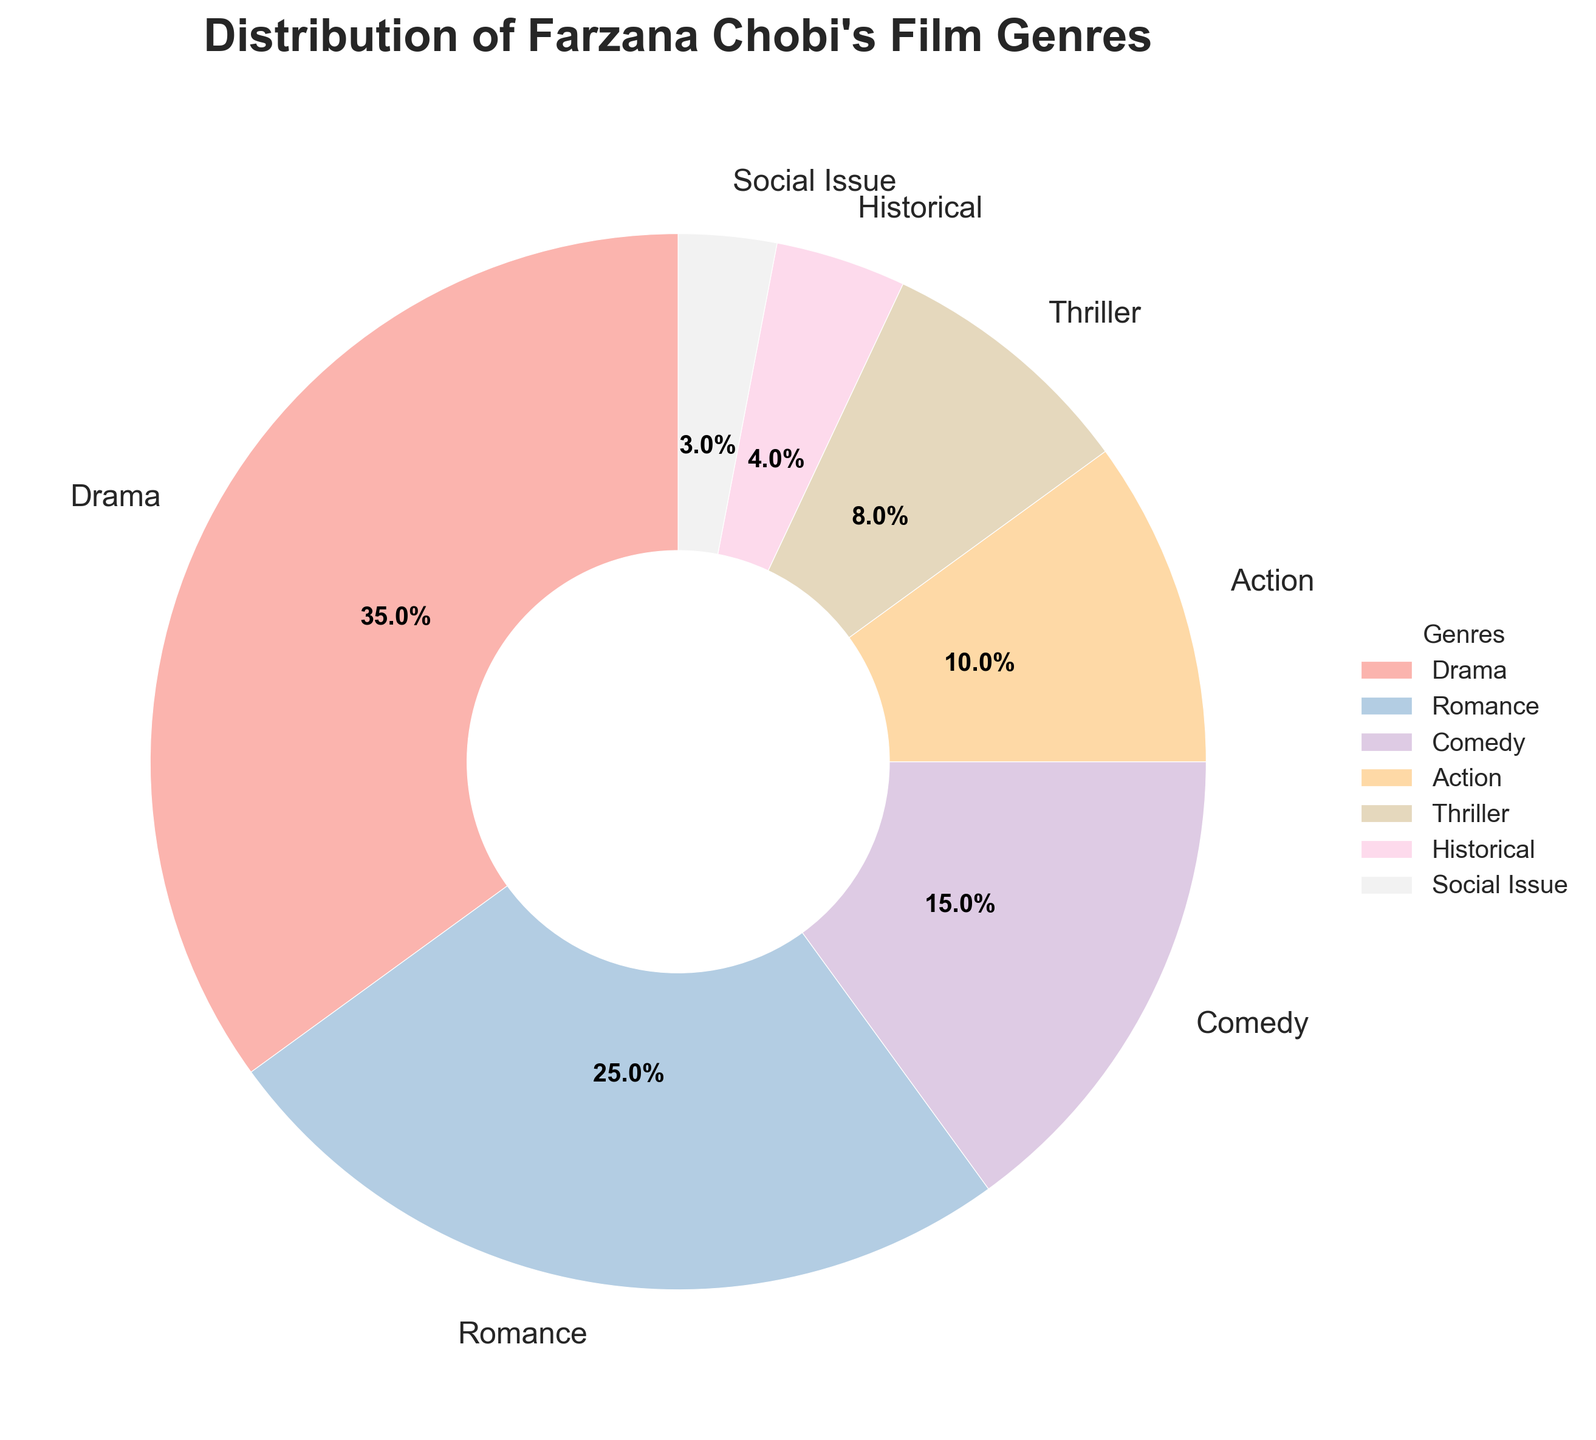What genre constitutes the largest percentage of Farzana Chobi's films? The largest segment on the pie chart is Drama. Hence, Drama constitutes the largest percentage of her films.
Answer: Drama What is the combined percentage of Drama and Romance films? From the chart, Drama is 35% and Romance is 25%. Summing them gives us 35 + 25 = 60%.
Answer: 60% Which category has a higher percentage, Comedy or Action? From the chart, Comedy has 15% and Action has 10%. Therefore, Comedy has a higher percentage than Action.
Answer: Comedy Which genre constitutes the smallest percentage of Farzana Chobi's films? The smallest segment on the pie chart is Social Issue with 3%.
Answer: Social Issue How much more percentage does Drama have compared to Thriller? Drama is 35% and Thriller is 8%. The difference is 35 - 8 = 27%.
Answer: 27% What is the difference in percentages between Drama and Romance genres? Drama is 35% and Romance is 25%. The difference is 35 - 25 = 10%.
Answer: 10% If Historical and Social Issue genres are combined, what percentage would they constitute? Historical is 4% and Social Issue is 3%. Combined, they would be 4 + 3 = 7%.
Answer: 7% Which categories constitute less than 10% of the films? From the chart, categories less than 10% are Thriller (8%), Historical (4%), and Social Issue (3%).
Answer: Thriller, Historical, Social Issue What is the total percentage of Comedy, Action, and Thriller genres together? Comedy is 15%, Action is 10%, and Thriller is 8%. Combined, they are 15 + 10 + 8 = 33%.
Answer: 33% How many genres are there in the 'less than 10%' category? From the chart, Thriller (8%), Historical (4%), and Social Issue (3%) are all less than 10%. This makes three genres.
Answer: 3 genres 